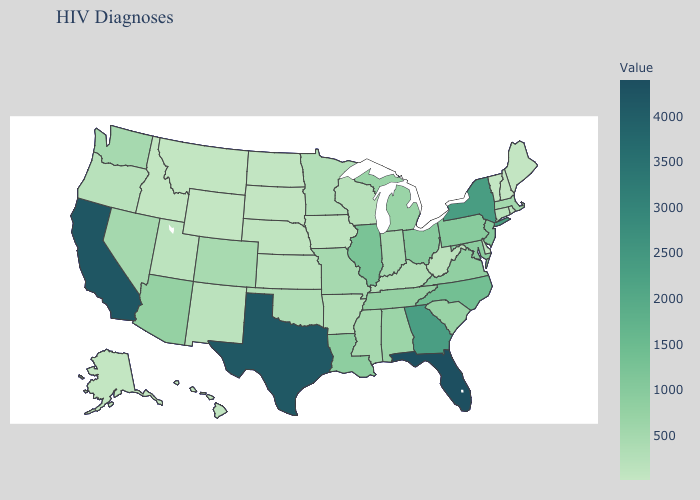Does Hawaii have a lower value than Georgia?
Be succinct. Yes. Does the map have missing data?
Concise answer only. No. Does Wyoming have the lowest value in the West?
Keep it brief. Yes. 